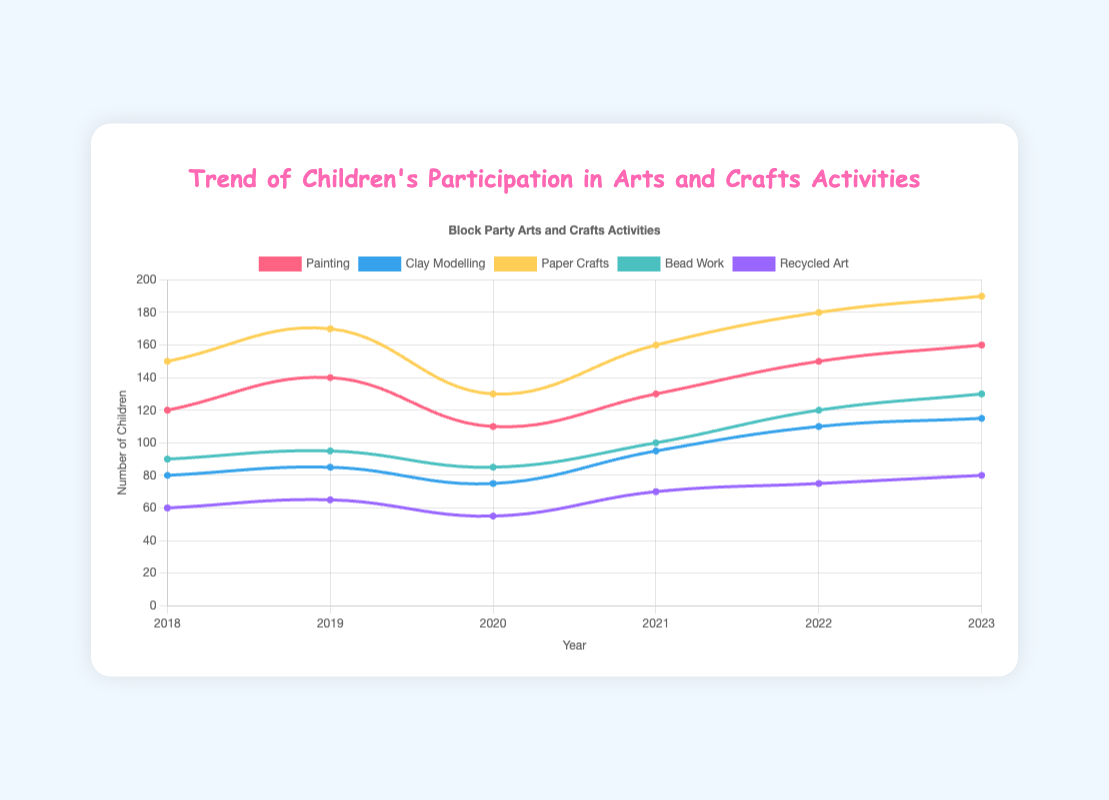Which activity saw the highest number of participating children in 2023? According to the figure, in 2023, Paper Crafts had the highest participation with 190 children.
Answer: Paper Crafts How did the participation in Recycled Art change from 2018 to 2023? The participation in Recycled Art increased from 60 children in 2018 to 80 children in 2023. This is a positive change of 20 children over 6 years.
Answer: Increased by 20 Which year saw the biggest drop in participation for Painting? Between 2019 and 2020, there was a decrease in participation for Painting from 140 children to 110 children, a drop of 30 children.
Answer: 2020 What's the average participation in Bead Work from 2018 to 2023? Sum up the number of children in Bead Work for each year: (90 + 95 + 85 + 100 + 120 + 130) = 620. Then divide by the number of years, 6: 620/6 = 103.33
Answer: 103.33 Which activities had a participation number greater than 100 in 2021? In 2021, Painting (130), Paper Crafts (160), and Bead Work (100) all had participation numbers greater than 100.
Answer: Painting, Paper Crafts, Bead Work Compare the changes in participation for Clay Modelling and Paper Crafts from 2018 to 2023. Which had a bigger increase? The participation for Clay Modelling increased from 80 to 115, an increase of 35 children. For Paper Crafts, it increased from 150 to 190, an increase of 40 children. Paper Crafts had a bigger increase.
Answer: Paper Crafts Did any activity see a decline in participation in 2020 when compared to the previous year? Yes, in 2020, both Painting and Clay Modelling saw declines in participation. Painting dropped from 140 to 110, and Clay Modelling from 85 to 75.
Answer: Yes, Painting and Clay Modelling What is the total number of children participated in all activities in 2019? To find the total, add up the participation numbers for all activities in 2019: 140 (Painting) + 85 (Clay Modelling) + 170 (Paper Crafts) + 95 (Bead Work) + 65 (Recycled Art) = 555.
Answer: 555 Which activity had the most consistent participation numbers from 2018 to 2023? Comparing the fluctuations in participation, Bead Work seems to have relatively consistent numbers, ranging from 85 to 130 with minor year-to-year changes.
Answer: Bead Work 